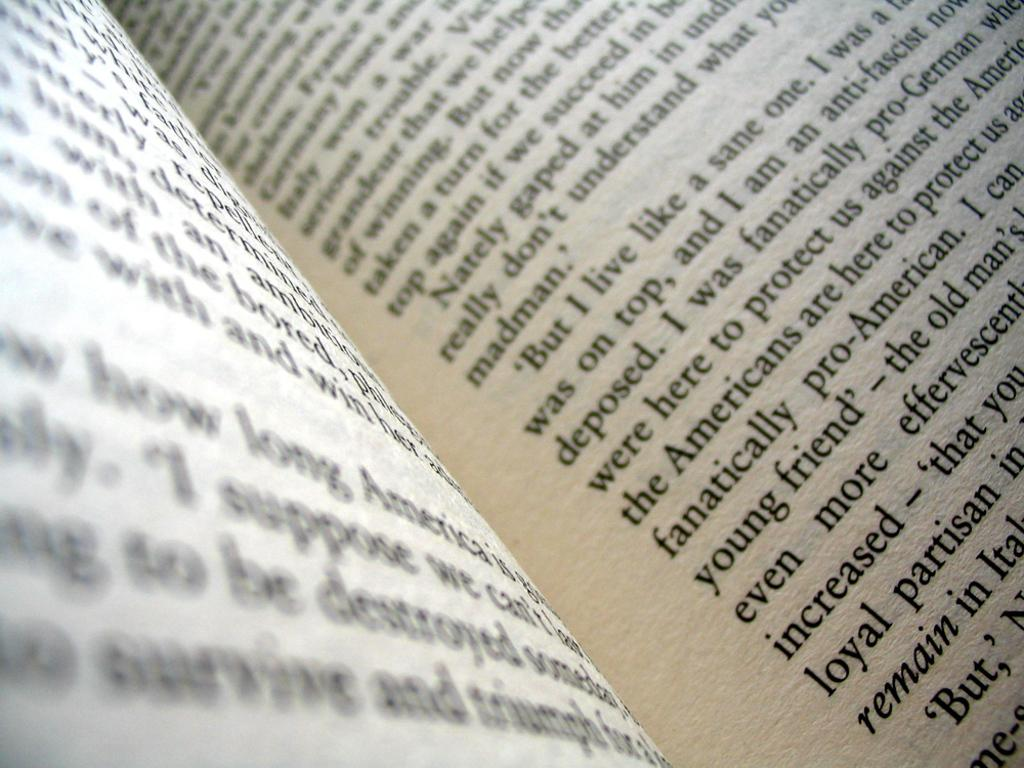<image>
Describe the image concisely. A book page has a paragraph that starts wtih but I live like a sane one. 